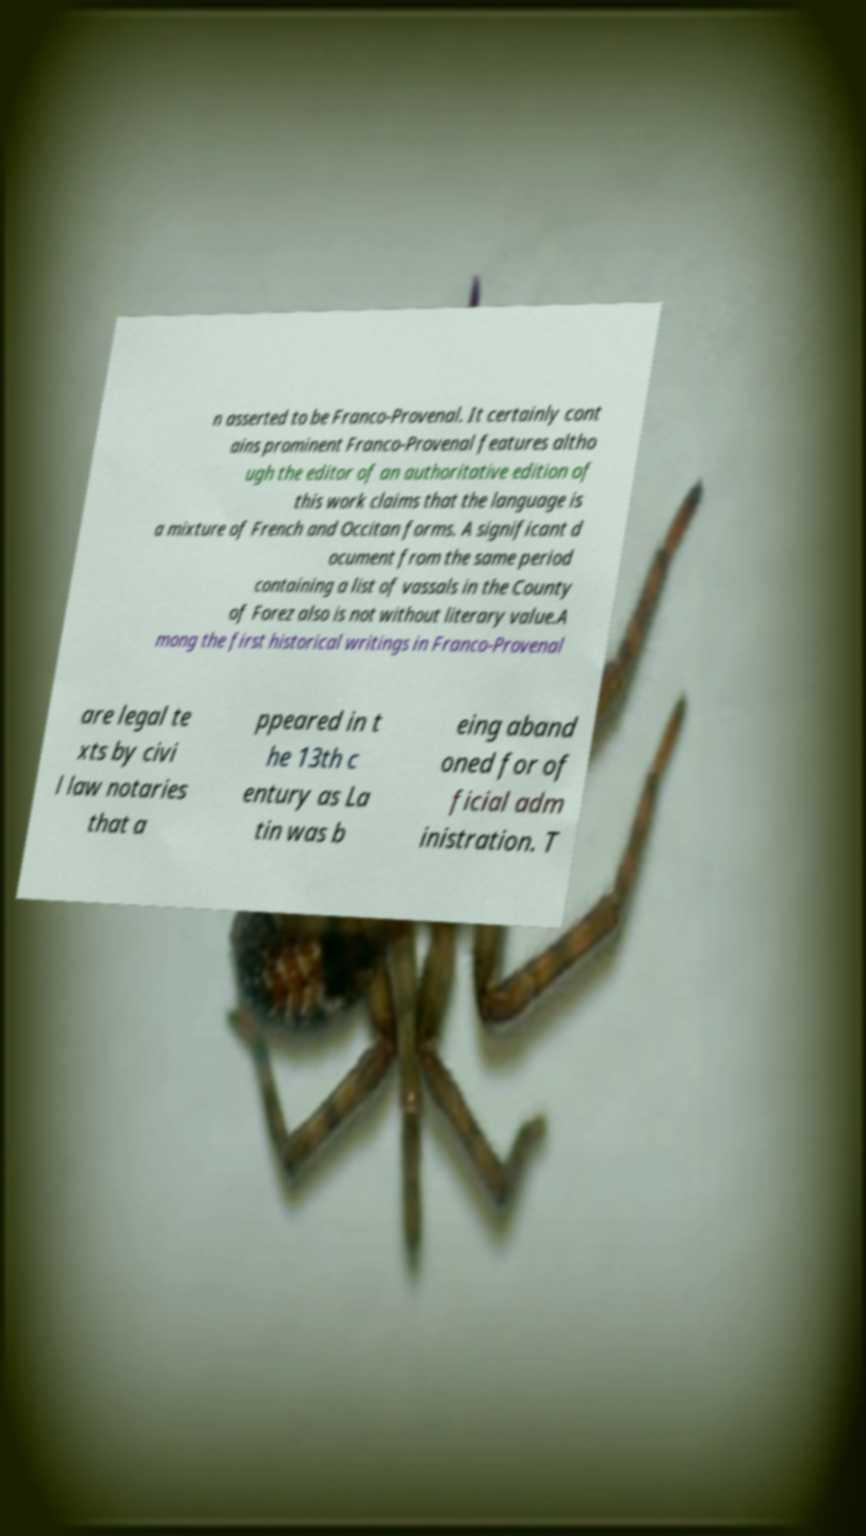What messages or text are displayed in this image? I need them in a readable, typed format. n asserted to be Franco-Provenal. It certainly cont ains prominent Franco-Provenal features altho ugh the editor of an authoritative edition of this work claims that the language is a mixture of French and Occitan forms. A significant d ocument from the same period containing a list of vassals in the County of Forez also is not without literary value.A mong the first historical writings in Franco-Provenal are legal te xts by civi l law notaries that a ppeared in t he 13th c entury as La tin was b eing aband oned for of ficial adm inistration. T 